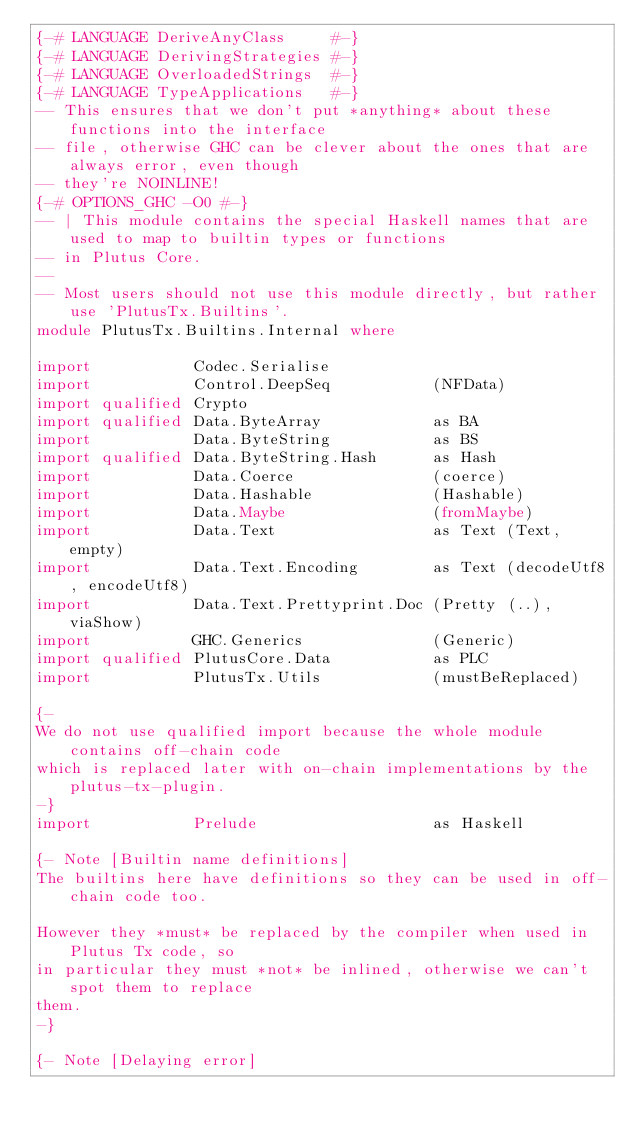Convert code to text. <code><loc_0><loc_0><loc_500><loc_500><_Haskell_>{-# LANGUAGE DeriveAnyClass     #-}
{-# LANGUAGE DerivingStrategies #-}
{-# LANGUAGE OverloadedStrings  #-}
{-# LANGUAGE TypeApplications   #-}
-- This ensures that we don't put *anything* about these functions into the interface
-- file, otherwise GHC can be clever about the ones that are always error, even though
-- they're NOINLINE!
{-# OPTIONS_GHC -O0 #-}
-- | This module contains the special Haskell names that are used to map to builtin types or functions
-- in Plutus Core.
--
-- Most users should not use this module directly, but rather use 'PlutusTx.Builtins'.
module PlutusTx.Builtins.Internal where

import           Codec.Serialise
import           Control.DeepSeq           (NFData)
import qualified Crypto
import qualified Data.ByteArray            as BA
import           Data.ByteString           as BS
import qualified Data.ByteString.Hash      as Hash
import           Data.Coerce               (coerce)
import           Data.Hashable             (Hashable)
import           Data.Maybe                (fromMaybe)
import           Data.Text                 as Text (Text, empty)
import           Data.Text.Encoding        as Text (decodeUtf8, encodeUtf8)
import           Data.Text.Prettyprint.Doc (Pretty (..), viaShow)
import           GHC.Generics              (Generic)
import qualified PlutusCore.Data           as PLC
import           PlutusTx.Utils            (mustBeReplaced)

{-
We do not use qualified import because the whole module contains off-chain code
which is replaced later with on-chain implementations by the plutus-tx-plugin.
-}
import           Prelude                   as Haskell

{- Note [Builtin name definitions]
The builtins here have definitions so they can be used in off-chain code too.

However they *must* be replaced by the compiler when used in Plutus Tx code, so
in particular they must *not* be inlined, otherwise we can't spot them to replace
them.
-}

{- Note [Delaying error]</code> 